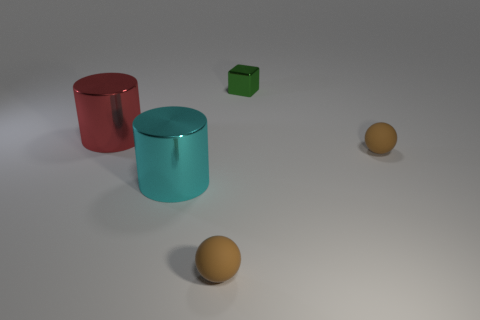Can you describe the shape of the objects and their arrangement on the surface? Sure, in the image we have two cylinders, one green cube, and two spheres. The cylinders are placed vertically with their circular faces on the ground, the cube is positioned with one of its square faces on the surface, and the spheres are, as expected, resting without a specific orientation due to their perfect symmetry. They are all arranged with some space between them, none touching the other. 